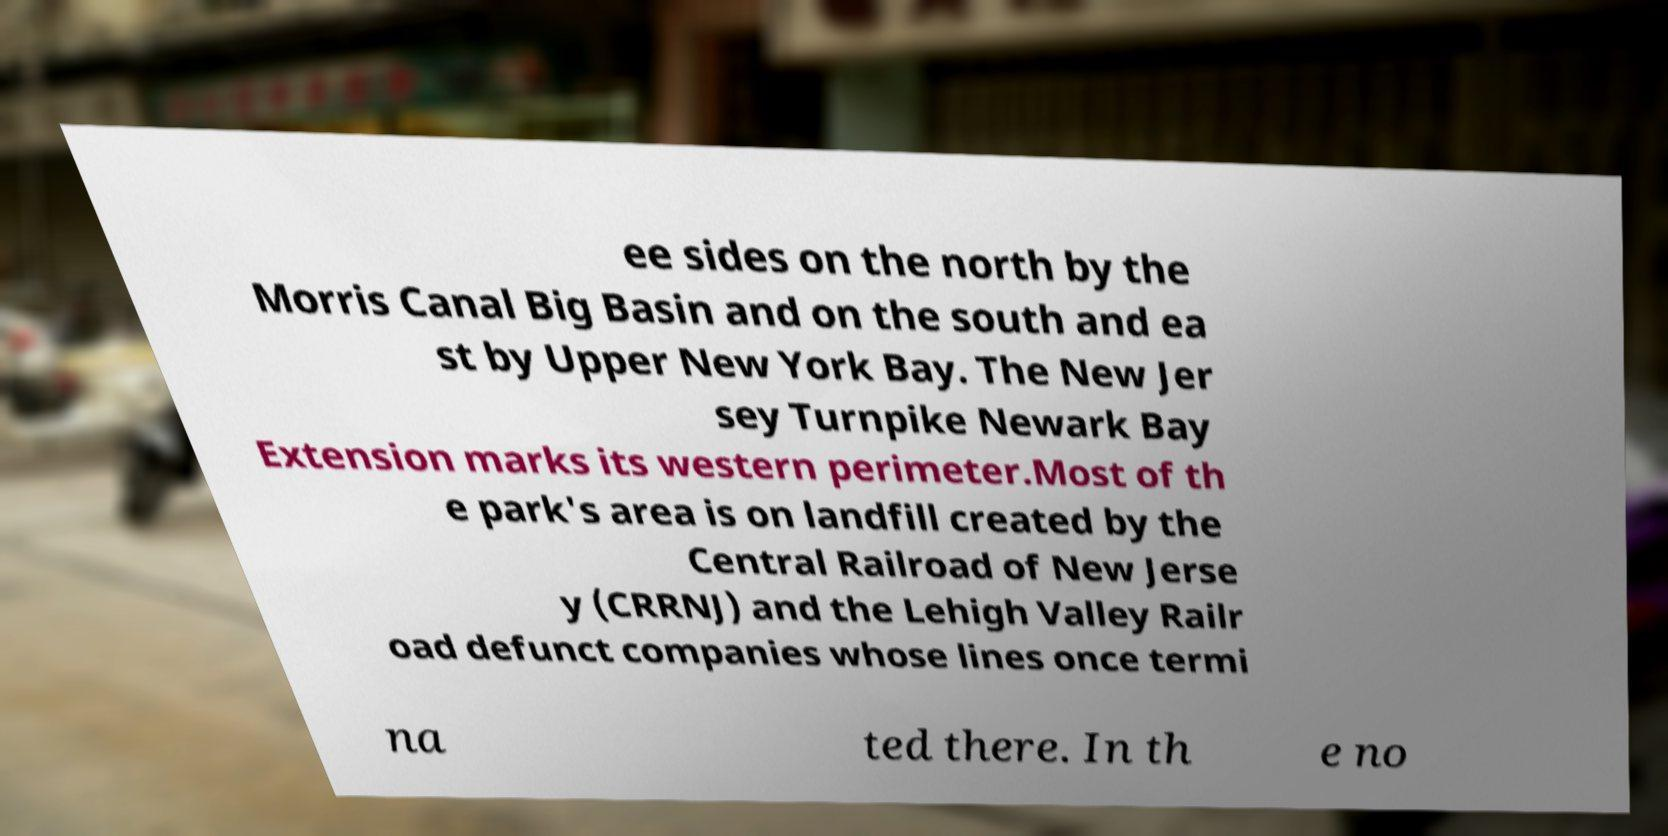There's text embedded in this image that I need extracted. Can you transcribe it verbatim? ee sides on the north by the Morris Canal Big Basin and on the south and ea st by Upper New York Bay. The New Jer sey Turnpike Newark Bay Extension marks its western perimeter.Most of th e park's area is on landfill created by the Central Railroad of New Jerse y (CRRNJ) and the Lehigh Valley Railr oad defunct companies whose lines once termi na ted there. In th e no 